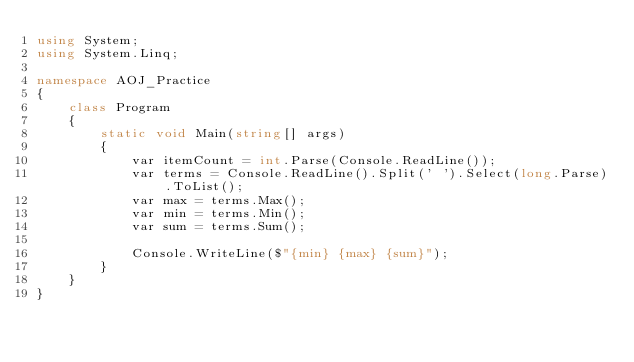Convert code to text. <code><loc_0><loc_0><loc_500><loc_500><_C#_>using System;
using System.Linq;

namespace AOJ_Practice
{
    class Program
    {
        static void Main(string[] args)
        {
            var itemCount = int.Parse(Console.ReadLine());
            var terms = Console.ReadLine().Split(' ').Select(long.Parse).ToList();
            var max = terms.Max();
            var min = terms.Min();
            var sum = terms.Sum();

            Console.WriteLine($"{min} {max} {sum}");
        }
    }
}

</code> 